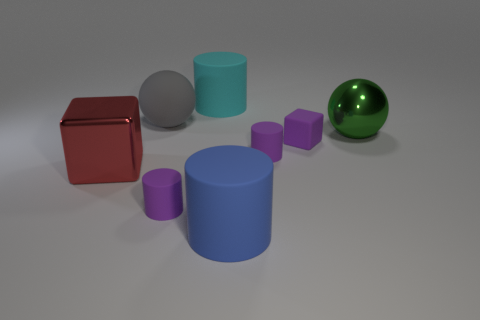There is a red metal thing; how many red metallic objects are to the left of it?
Your response must be concise. 0. The blue thing has what size?
Give a very brief answer. Large. There is a block that is the same material as the green object; what is its color?
Offer a terse response. Red. What number of cyan cylinders are the same size as the gray rubber object?
Provide a short and direct response. 1. Is the large ball left of the green shiny ball made of the same material as the small cube?
Your answer should be very brief. Yes. Are there fewer large gray matte balls that are in front of the big green shiny thing than small purple shiny cylinders?
Provide a succinct answer. No. There is a shiny object that is left of the green object; what shape is it?
Offer a very short reply. Cube. What is the shape of the gray matte object that is the same size as the green ball?
Offer a terse response. Sphere. Is there a big gray thing that has the same shape as the green shiny thing?
Provide a short and direct response. Yes. Do the metallic thing to the right of the big blue cylinder and the big shiny thing to the left of the big cyan cylinder have the same shape?
Offer a terse response. No. 